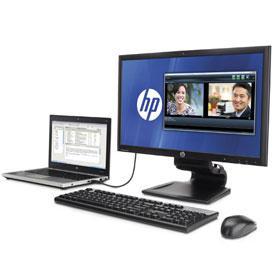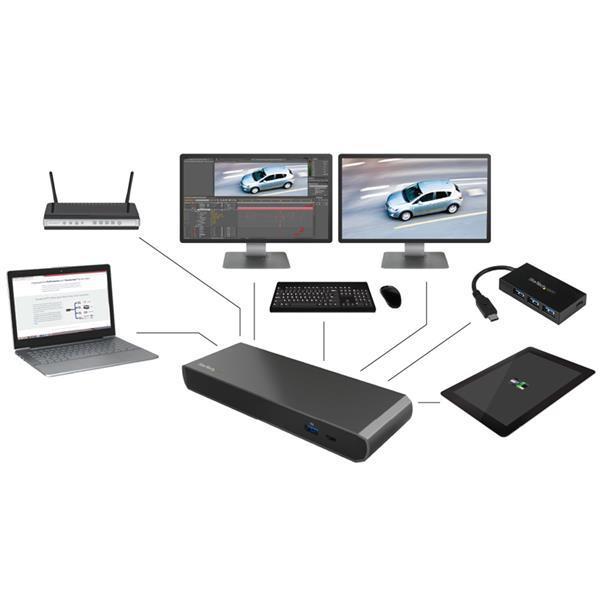The first image is the image on the left, the second image is the image on the right. Given the left and right images, does the statement "there is a monitor with a keyboard in front of it and a mouse to the right of the keyboard" hold true? Answer yes or no. Yes. The first image is the image on the left, the second image is the image on the right. Considering the images on both sides, is "In at least one image there are two separate electronic  powered on with a black wireless keyboard in front of the computer monitor." valid? Answer yes or no. Yes. 